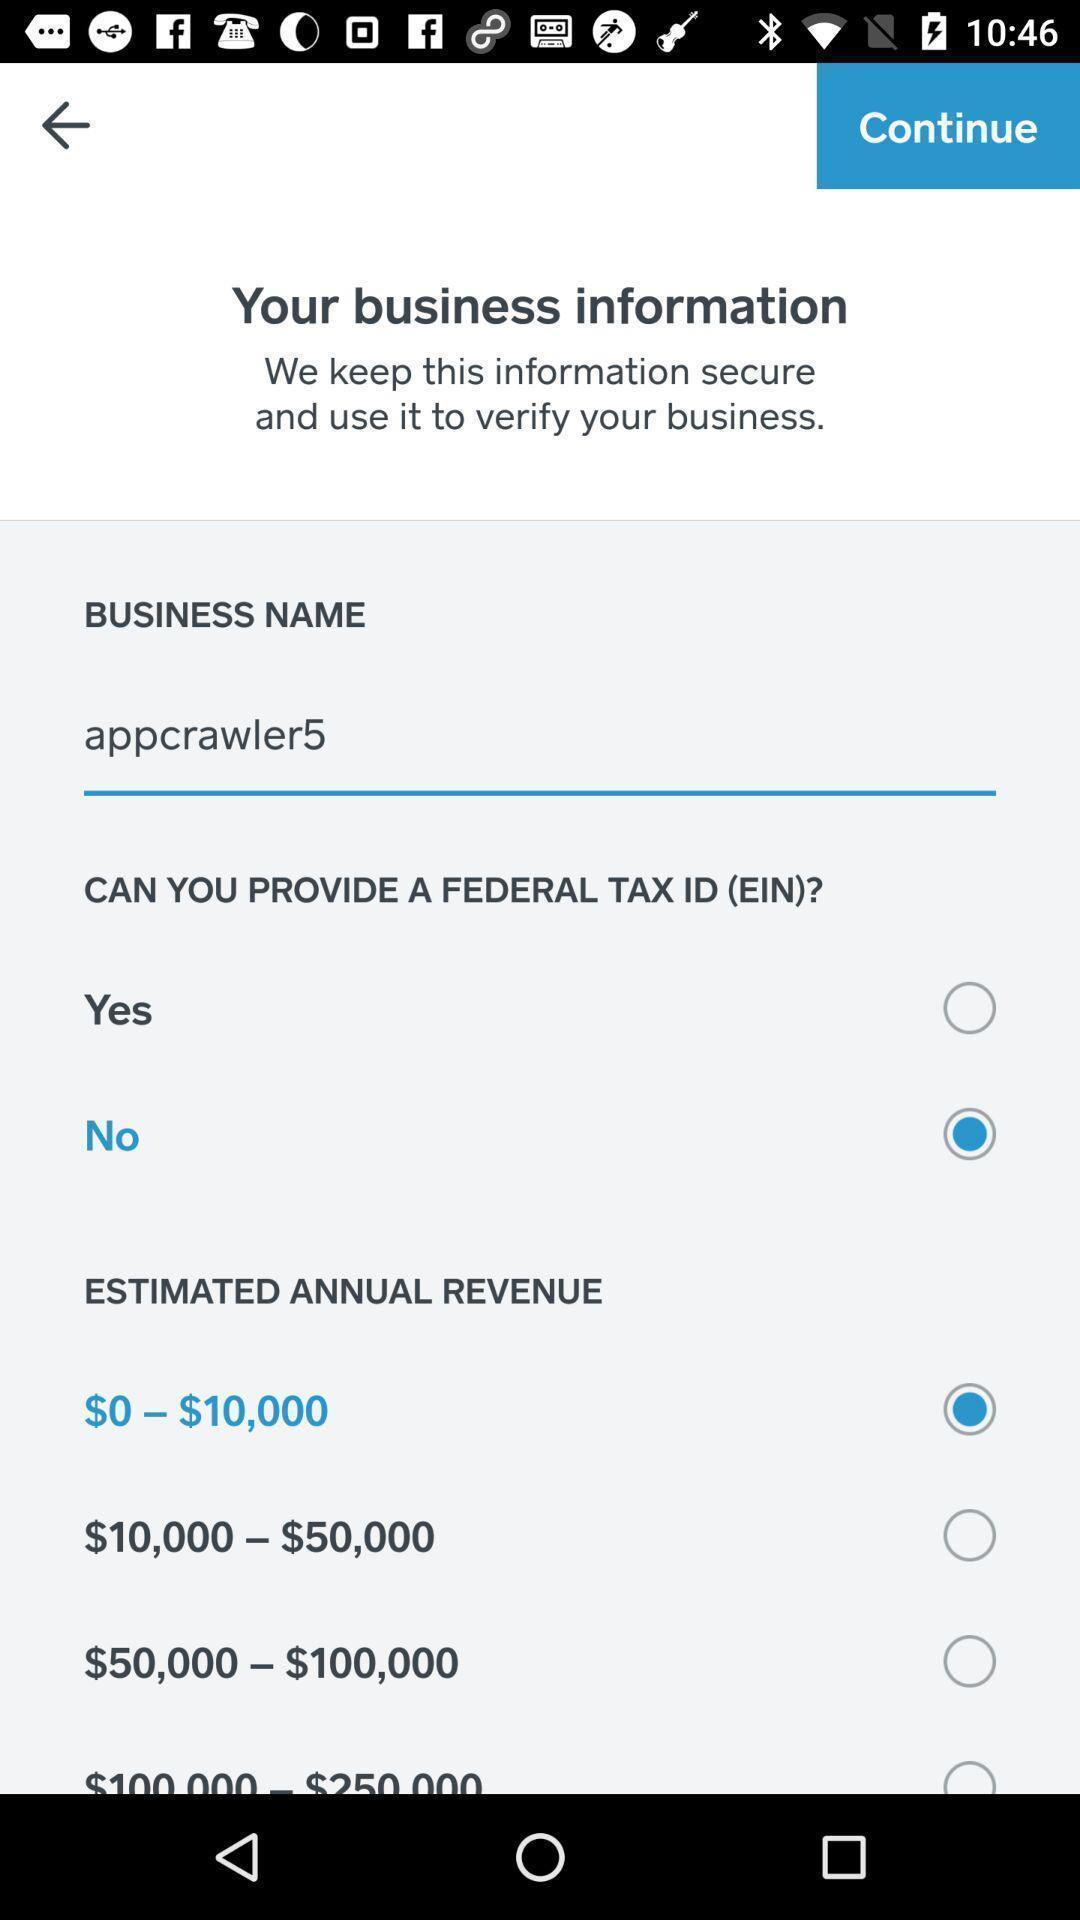Describe the key features of this screenshot. Page showing different options on an app. 